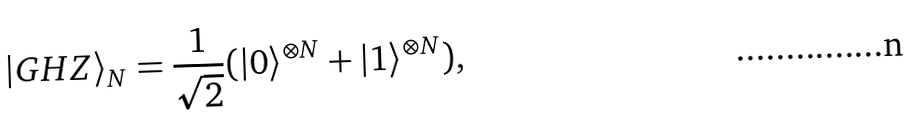<formula> <loc_0><loc_0><loc_500><loc_500>| G H Z \rangle _ { N } = \frac { 1 } { \sqrt { 2 } } ( | 0 \rangle ^ { \otimes N } + | 1 \rangle ^ { \otimes N } ) ,</formula> 